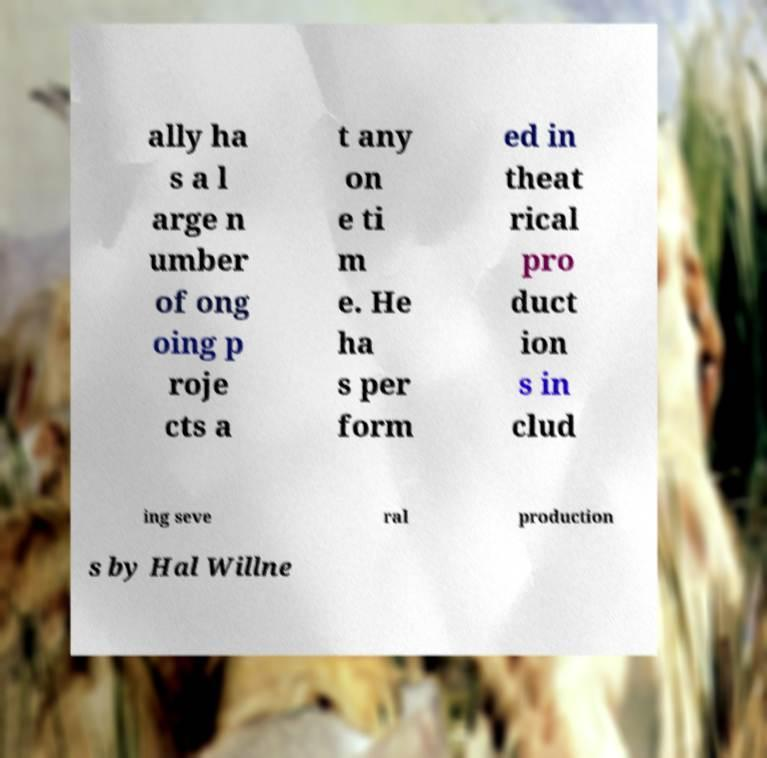What messages or text are displayed in this image? I need them in a readable, typed format. ally ha s a l arge n umber of ong oing p roje cts a t any on e ti m e. He ha s per form ed in theat rical pro duct ion s in clud ing seve ral production s by Hal Willne 